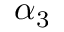Convert formula to latex. <formula><loc_0><loc_0><loc_500><loc_500>\alpha _ { 3 }</formula> 